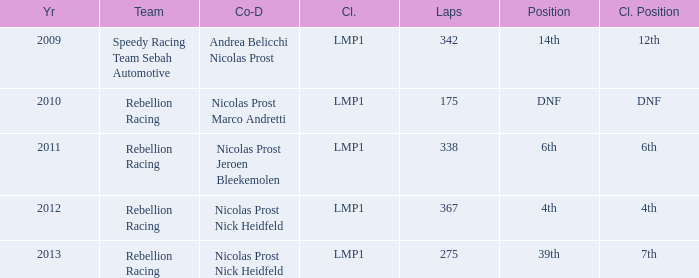What is Class Pos., when Year is before 2013, and when Laps is greater than 175? 12th, 6th, 4th. 